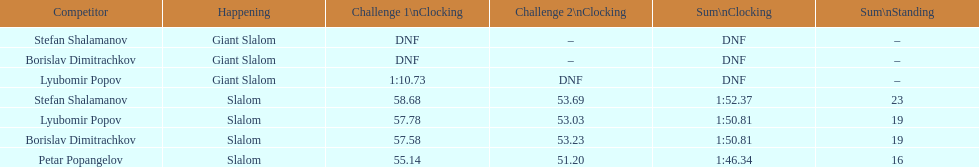What is the number of athletes to finish race one in the giant slalom? 1. 